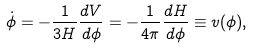<formula> <loc_0><loc_0><loc_500><loc_500>\dot { \phi } = - \frac { 1 } { 3 H } \frac { d V } { d \phi } = - \frac { 1 } { 4 \pi } \frac { d H } { d \phi } \equiv v ( \phi ) ,</formula> 